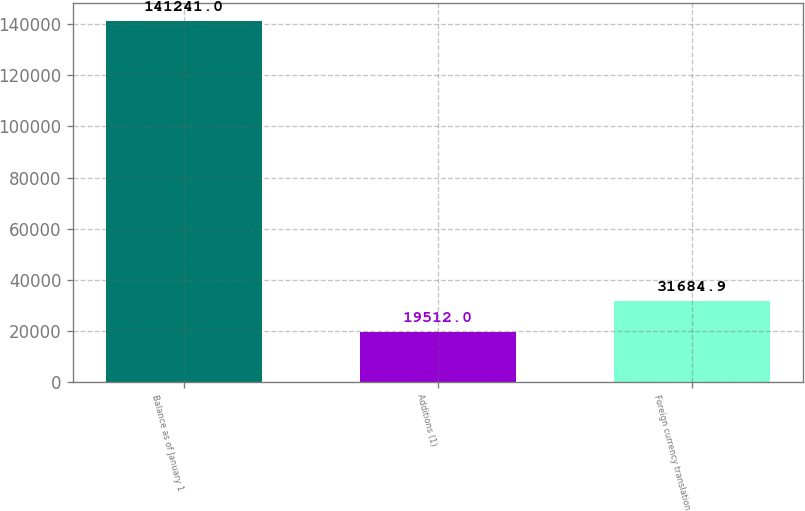Convert chart. <chart><loc_0><loc_0><loc_500><loc_500><bar_chart><fcel>Balance as of January 1<fcel>Additions (1)<fcel>Foreign currency translation<nl><fcel>141241<fcel>19512<fcel>31684.9<nl></chart> 